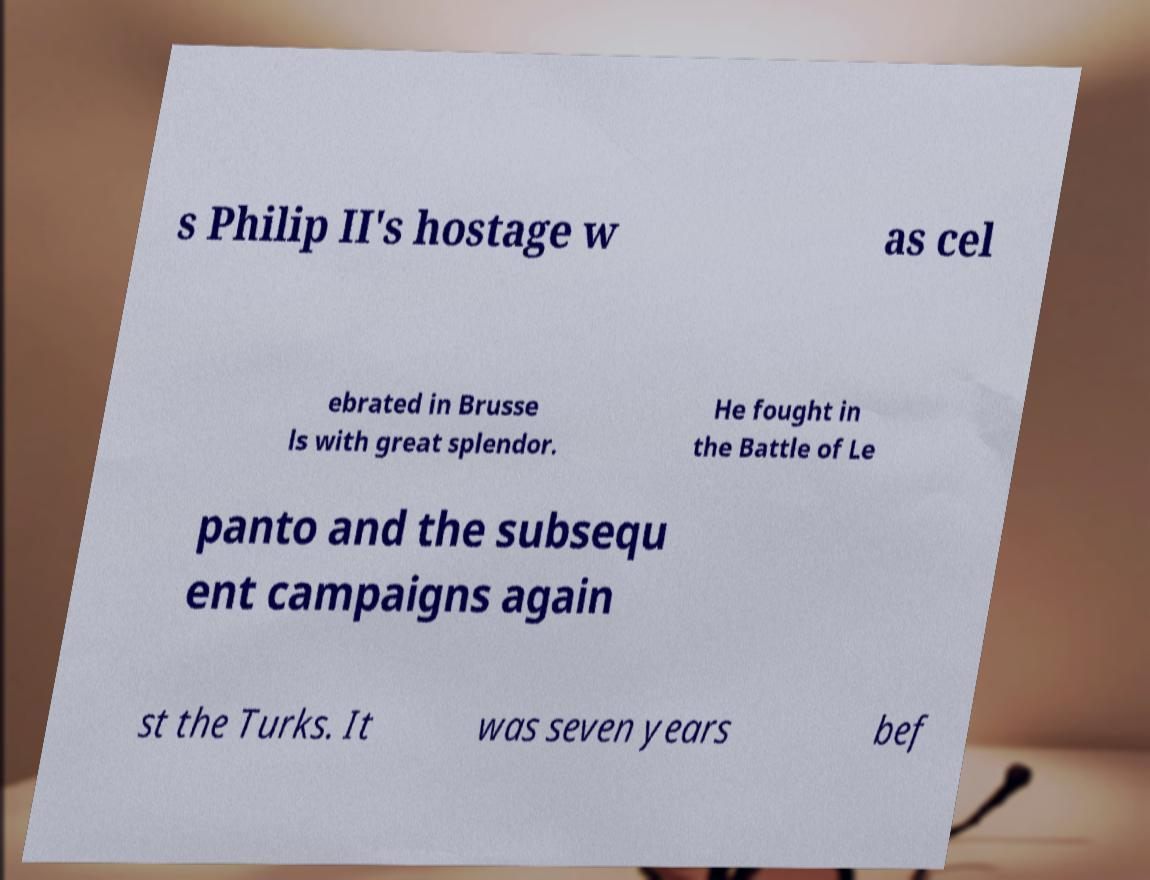Could you assist in decoding the text presented in this image and type it out clearly? s Philip II's hostage w as cel ebrated in Brusse ls with great splendor. He fought in the Battle of Le panto and the subsequ ent campaigns again st the Turks. It was seven years bef 